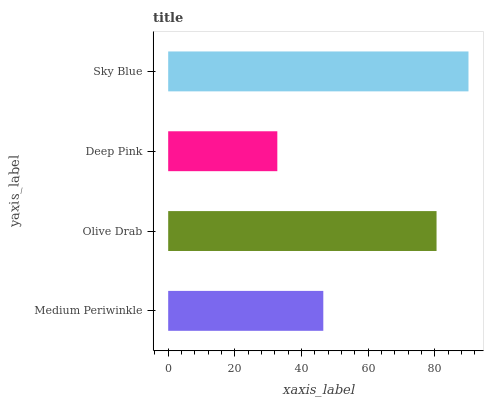Is Deep Pink the minimum?
Answer yes or no. Yes. Is Sky Blue the maximum?
Answer yes or no. Yes. Is Olive Drab the minimum?
Answer yes or no. No. Is Olive Drab the maximum?
Answer yes or no. No. Is Olive Drab greater than Medium Periwinkle?
Answer yes or no. Yes. Is Medium Periwinkle less than Olive Drab?
Answer yes or no. Yes. Is Medium Periwinkle greater than Olive Drab?
Answer yes or no. No. Is Olive Drab less than Medium Periwinkle?
Answer yes or no. No. Is Olive Drab the high median?
Answer yes or no. Yes. Is Medium Periwinkle the low median?
Answer yes or no. Yes. Is Deep Pink the high median?
Answer yes or no. No. Is Olive Drab the low median?
Answer yes or no. No. 